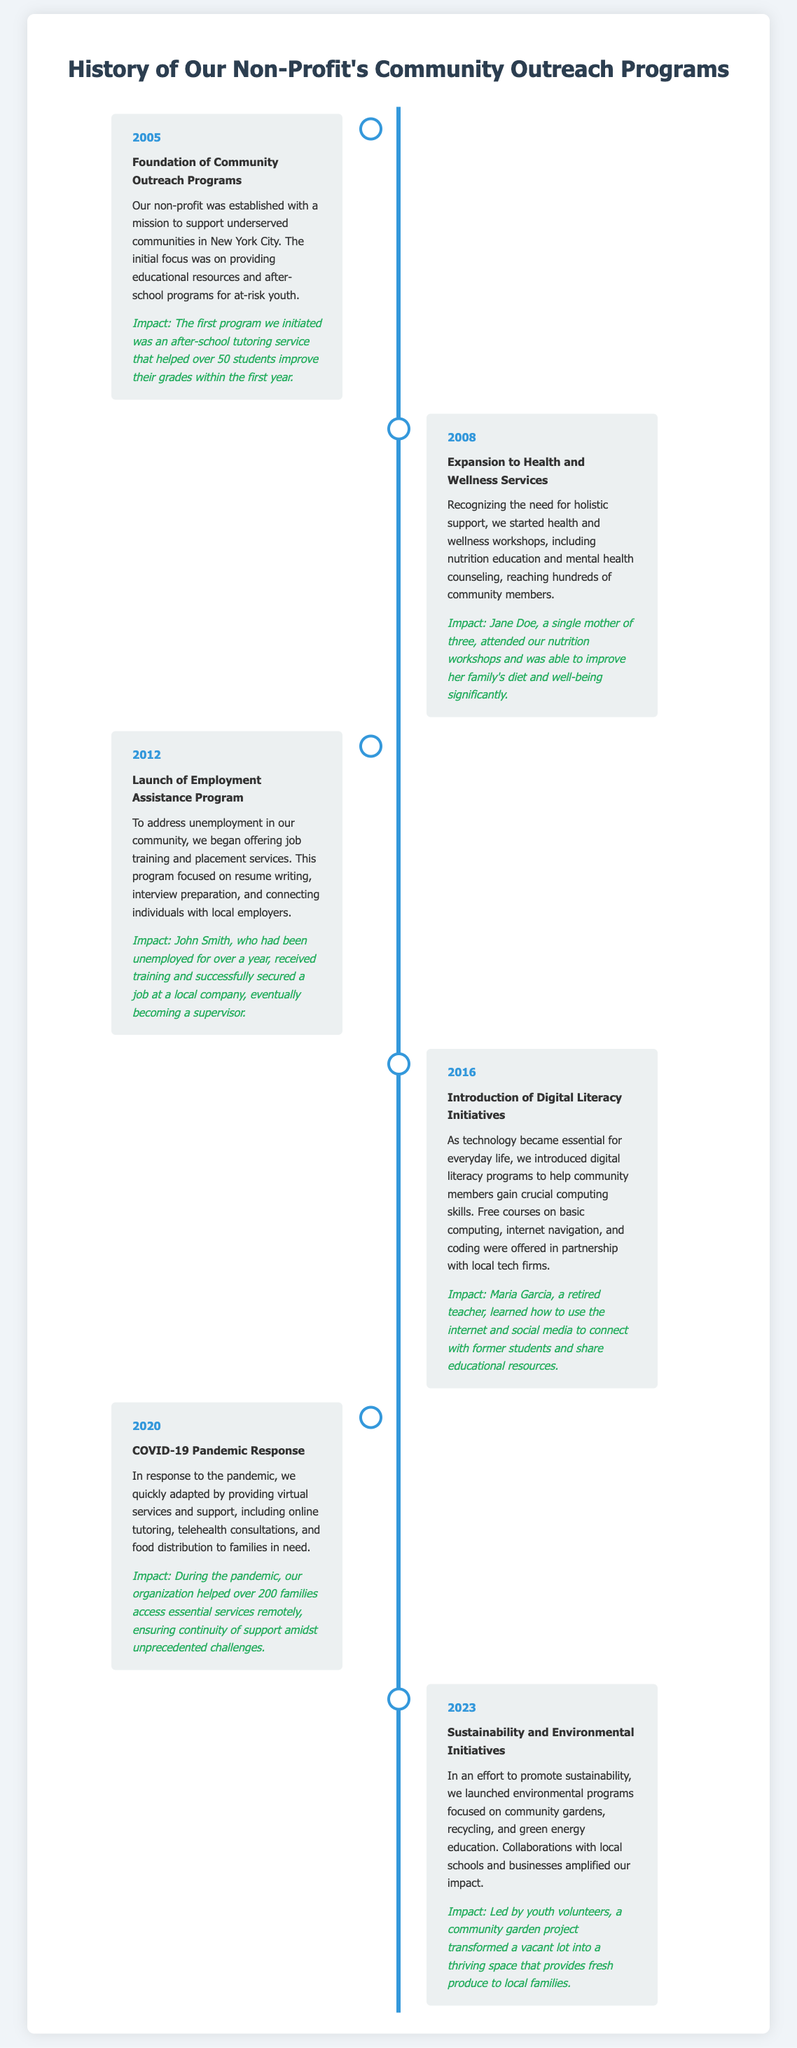What year was the non-profit established? The foundation of community outreach programs occurred in 2005.
Answer: 2005 Which program was launched in 2008? Health and wellness workshops were introduced as part of the expansion in 2008.
Answer: Health and wellness services Who benefited from the nutrition workshops in 2008? Jane Doe improved her family's diet and well-being significantly through the workshops.
Answer: Jane Doe What type of program was launched in 2012? The document states that an employment assistance program was launched in 2012 focusing on job training and placement.
Answer: Employment Assistance Program How many families did the organization help during the COVID-19 pandemic? The organization supported over 200 families with services during the pandemic.
Answer: Over 200 families What major initiative was introduced in 2016? Digital literacy initiatives were introduced in response to technological needs within the community.
Answer: Digital Literacy Initiatives What type of projects are highlighted for 2023? The sustainability and environmental initiatives included community gardens and recycling efforts.
Answer: Sustainability and Environmental Initiatives Who transformed a vacant lot into a community garden in 2023? Youth volunteers led the project for the community garden in 2023.
Answer: Youth volunteers 